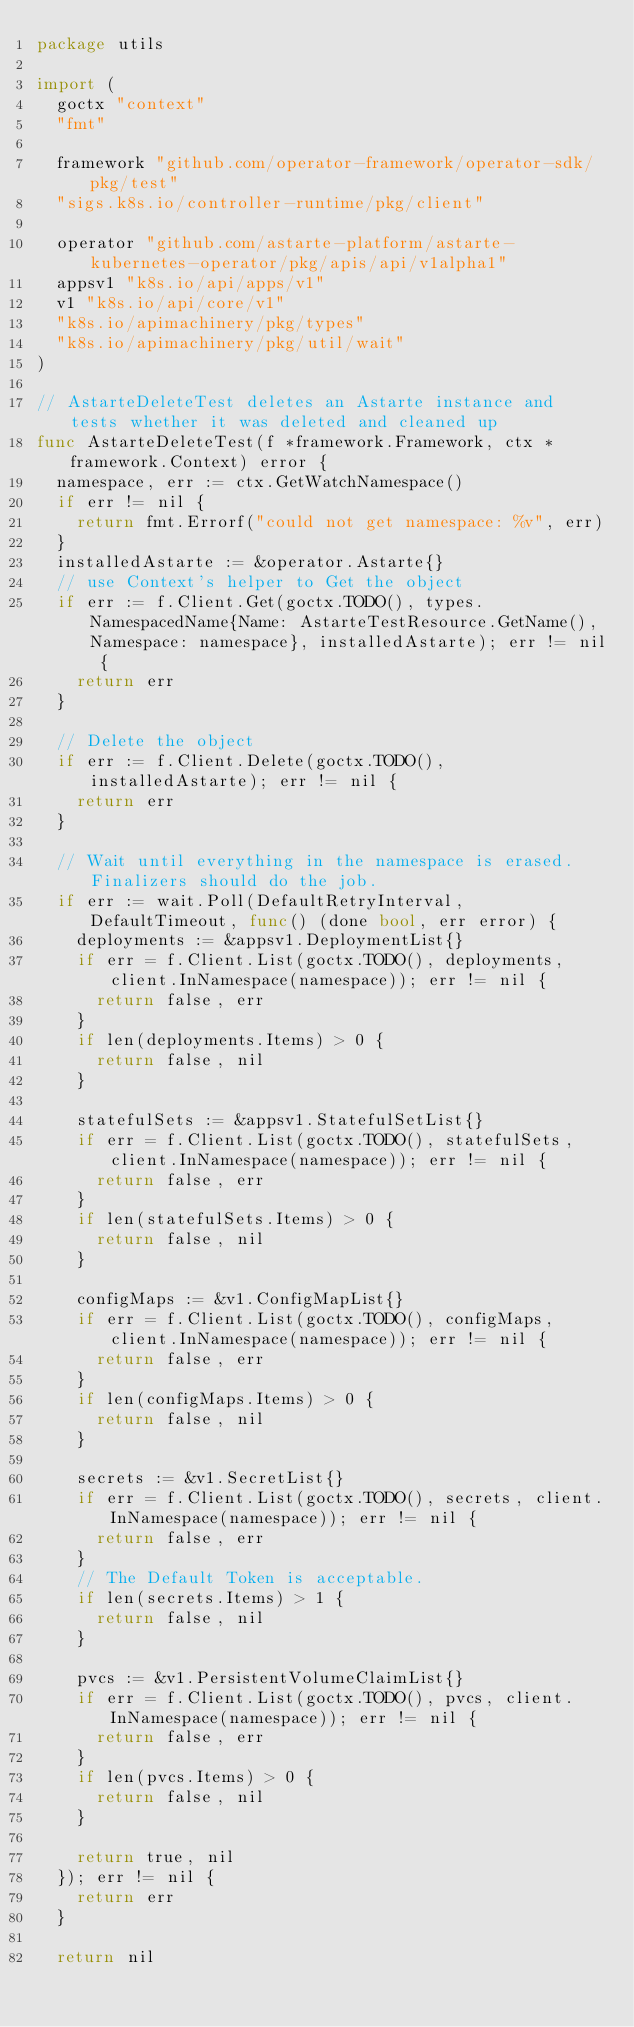<code> <loc_0><loc_0><loc_500><loc_500><_Go_>package utils

import (
	goctx "context"
	"fmt"

	framework "github.com/operator-framework/operator-sdk/pkg/test"
	"sigs.k8s.io/controller-runtime/pkg/client"

	operator "github.com/astarte-platform/astarte-kubernetes-operator/pkg/apis/api/v1alpha1"
	appsv1 "k8s.io/api/apps/v1"
	v1 "k8s.io/api/core/v1"
	"k8s.io/apimachinery/pkg/types"
	"k8s.io/apimachinery/pkg/util/wait"
)

// AstarteDeleteTest deletes an Astarte instance and tests whether it was deleted and cleaned up
func AstarteDeleteTest(f *framework.Framework, ctx *framework.Context) error {
	namespace, err := ctx.GetWatchNamespace()
	if err != nil {
		return fmt.Errorf("could not get namespace: %v", err)
	}
	installedAstarte := &operator.Astarte{}
	// use Context's helper to Get the object
	if err := f.Client.Get(goctx.TODO(), types.NamespacedName{Name: AstarteTestResource.GetName(), Namespace: namespace}, installedAstarte); err != nil {
		return err
	}

	// Delete the object
	if err := f.Client.Delete(goctx.TODO(), installedAstarte); err != nil {
		return err
	}

	// Wait until everything in the namespace is erased. Finalizers should do the job.
	if err := wait.Poll(DefaultRetryInterval, DefaultTimeout, func() (done bool, err error) {
		deployments := &appsv1.DeploymentList{}
		if err = f.Client.List(goctx.TODO(), deployments, client.InNamespace(namespace)); err != nil {
			return false, err
		}
		if len(deployments.Items) > 0 {
			return false, nil
		}

		statefulSets := &appsv1.StatefulSetList{}
		if err = f.Client.List(goctx.TODO(), statefulSets, client.InNamespace(namespace)); err != nil {
			return false, err
		}
		if len(statefulSets.Items) > 0 {
			return false, nil
		}

		configMaps := &v1.ConfigMapList{}
		if err = f.Client.List(goctx.TODO(), configMaps, client.InNamespace(namespace)); err != nil {
			return false, err
		}
		if len(configMaps.Items) > 0 {
			return false, nil
		}

		secrets := &v1.SecretList{}
		if err = f.Client.List(goctx.TODO(), secrets, client.InNamespace(namespace)); err != nil {
			return false, err
		}
		// The Default Token is acceptable.
		if len(secrets.Items) > 1 {
			return false, nil
		}

		pvcs := &v1.PersistentVolumeClaimList{}
		if err = f.Client.List(goctx.TODO(), pvcs, client.InNamespace(namespace)); err != nil {
			return false, err
		}
		if len(pvcs.Items) > 0 {
			return false, nil
		}

		return true, nil
	}); err != nil {
		return err
	}

	return nil</code> 